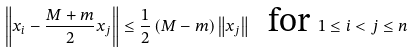<formula> <loc_0><loc_0><loc_500><loc_500>\left \| x _ { i } - \frac { M + m } { 2 } x _ { j } \right \| \leq \frac { 1 } { 2 } \left ( M - m \right ) \left \| x _ { j } \right \| \text { \ for } 1 \leq i < j \leq n</formula> 